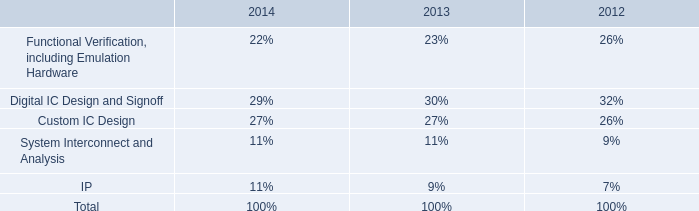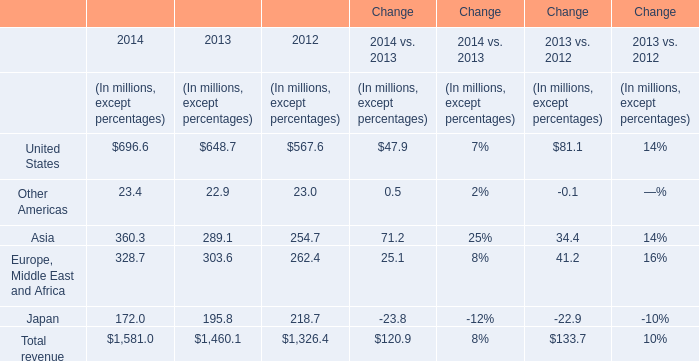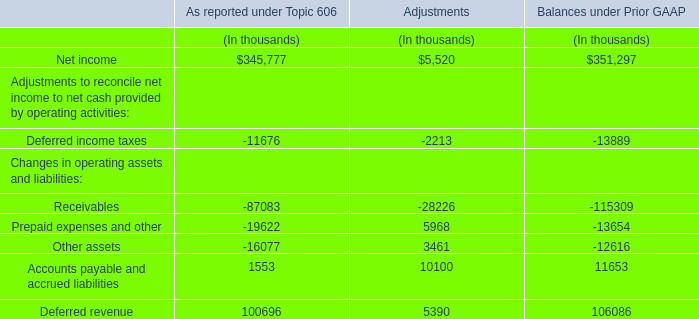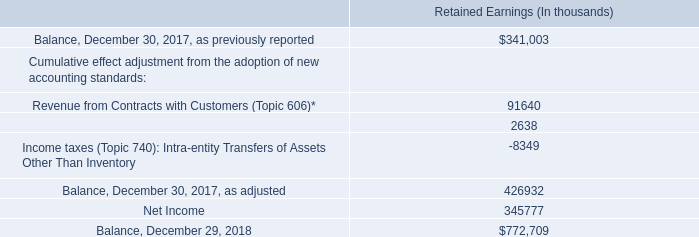What is the difference between the greatest United States in 2013 and 2012？ (in millions) 
Computations: (648.7 - 567.6)
Answer: 81.1. 